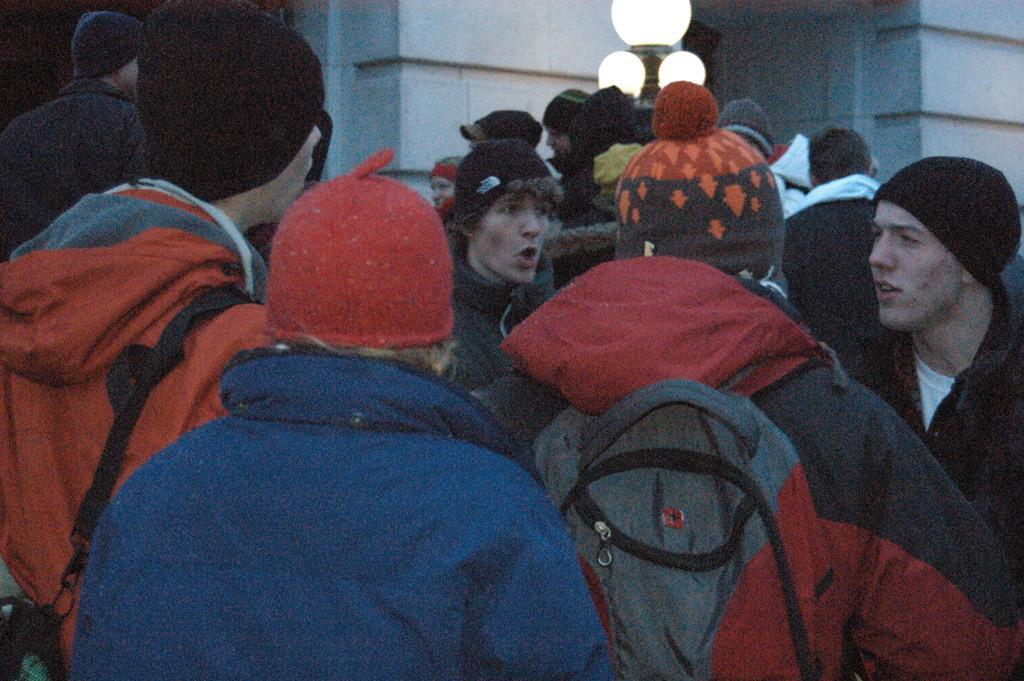Describe this image in one or two sentences. In this image we can see a group of people. They are wearing a jacket and here we can see the monkey caps on their heads. Here we can see the bags on their back. Here we can see a light pole. 